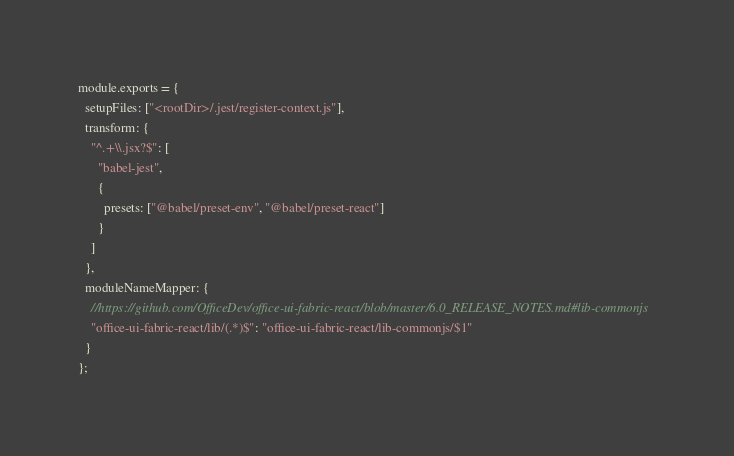Convert code to text. <code><loc_0><loc_0><loc_500><loc_500><_JavaScript_>module.exports = {
  setupFiles: ["<rootDir>/.jest/register-context.js"],
  transform: {
    "^.+\\.jsx?$": [
      "babel-jest",
      {
        presets: ["@babel/preset-env", "@babel/preset-react"]
      }
    ]
  },
  moduleNameMapper: {
    //https://github.com/OfficeDev/office-ui-fabric-react/blob/master/6.0_RELEASE_NOTES.md#lib-commonjs
    "office-ui-fabric-react/lib/(.*)$": "office-ui-fabric-react/lib-commonjs/$1"
  }
};
</code> 